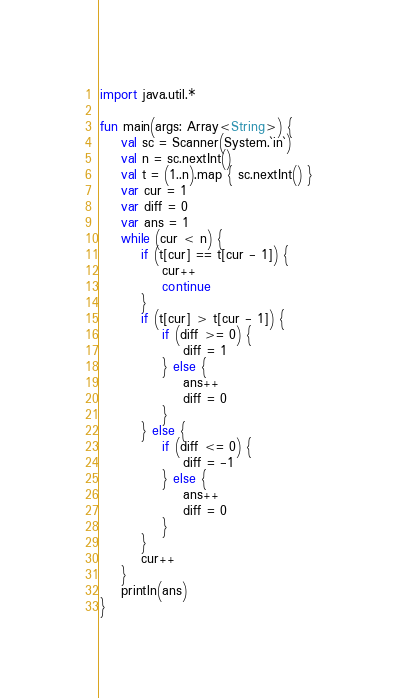<code> <loc_0><loc_0><loc_500><loc_500><_Kotlin_>import java.util.*
 
fun main(args: Array<String>) {
    val sc = Scanner(System.`in`)
    val n = sc.nextInt()
    val t = (1..n).map { sc.nextInt() }
    var cur = 1
    var diff = 0
    var ans = 1
    while (cur < n) {
        if (t[cur] == t[cur - 1]) {
            cur++
            continue
        }
        if (t[cur] > t[cur - 1]) {
            if (diff >= 0) {
                diff = 1
            } else {
                ans++
                diff = 0
            }
        } else {
            if (diff <= 0) {
                diff = -1
            } else {
                ans++
                diff = 0
            }
        }
        cur++
    }
    println(ans)
}</code> 